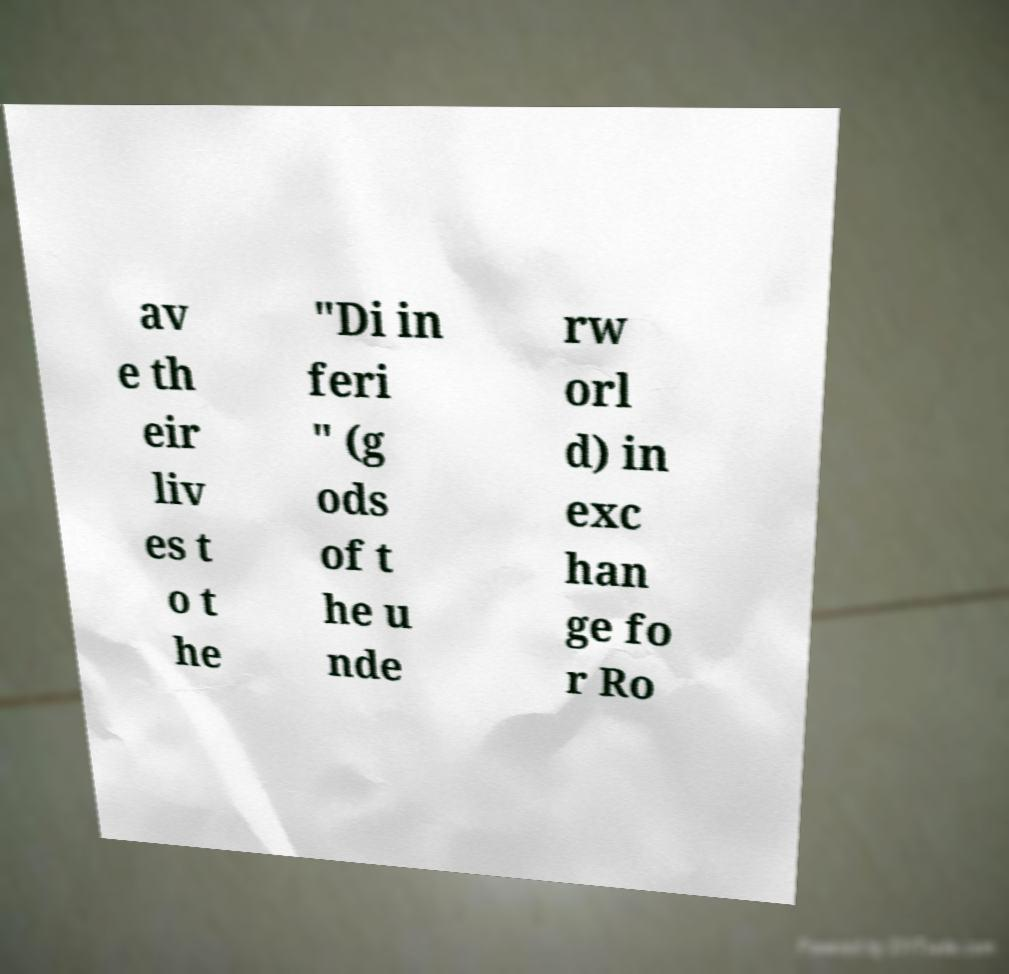Please identify and transcribe the text found in this image. av e th eir liv es t o t he "Di in feri " (g ods of t he u nde rw orl d) in exc han ge fo r Ro 